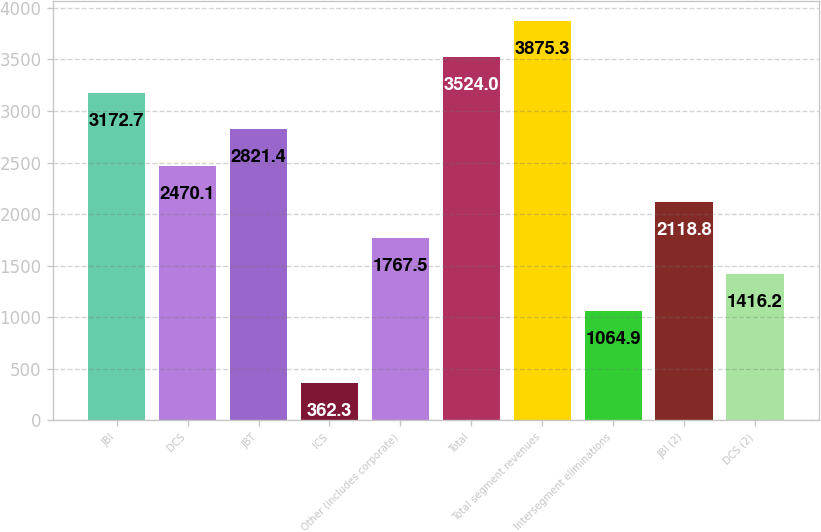Convert chart. <chart><loc_0><loc_0><loc_500><loc_500><bar_chart><fcel>JBI<fcel>DCS<fcel>JBT<fcel>ICS<fcel>Other (includes corporate)<fcel>Total<fcel>Total segment revenues<fcel>Intersegment eliminations<fcel>JBI (2)<fcel>DCS (2)<nl><fcel>3172.7<fcel>2470.1<fcel>2821.4<fcel>362.3<fcel>1767.5<fcel>3524<fcel>3875.3<fcel>1064.9<fcel>2118.8<fcel>1416.2<nl></chart> 